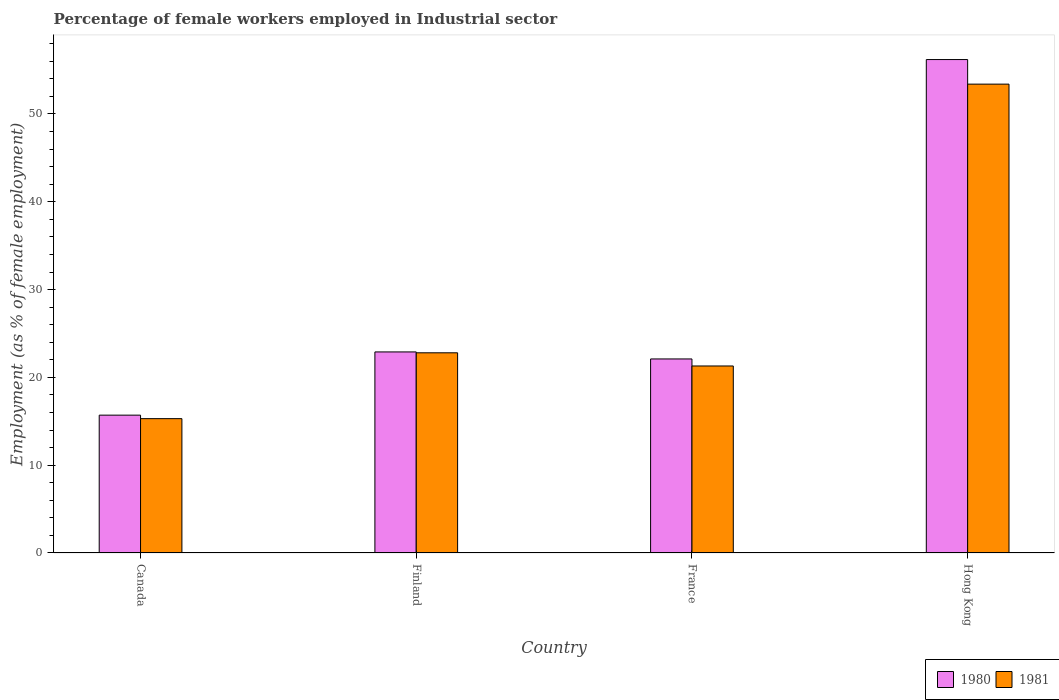How many bars are there on the 2nd tick from the left?
Ensure brevity in your answer.  2. How many bars are there on the 4th tick from the right?
Your answer should be compact. 2. What is the percentage of females employed in Industrial sector in 1980 in Canada?
Ensure brevity in your answer.  15.7. Across all countries, what is the maximum percentage of females employed in Industrial sector in 1981?
Ensure brevity in your answer.  53.4. Across all countries, what is the minimum percentage of females employed in Industrial sector in 1980?
Provide a succinct answer. 15.7. In which country was the percentage of females employed in Industrial sector in 1980 maximum?
Ensure brevity in your answer.  Hong Kong. What is the total percentage of females employed in Industrial sector in 1981 in the graph?
Give a very brief answer. 112.8. What is the difference between the percentage of females employed in Industrial sector in 1980 in Finland and that in France?
Offer a terse response. 0.8. What is the difference between the percentage of females employed in Industrial sector in 1980 in Finland and the percentage of females employed in Industrial sector in 1981 in Hong Kong?
Give a very brief answer. -30.5. What is the average percentage of females employed in Industrial sector in 1980 per country?
Your answer should be compact. 29.23. What is the difference between the percentage of females employed in Industrial sector of/in 1980 and percentage of females employed in Industrial sector of/in 1981 in Finland?
Your answer should be compact. 0.1. In how many countries, is the percentage of females employed in Industrial sector in 1980 greater than 40 %?
Your response must be concise. 1. What is the ratio of the percentage of females employed in Industrial sector in 1980 in Canada to that in France?
Your response must be concise. 0.71. Is the difference between the percentage of females employed in Industrial sector in 1980 in Finland and Hong Kong greater than the difference between the percentage of females employed in Industrial sector in 1981 in Finland and Hong Kong?
Provide a short and direct response. No. What is the difference between the highest and the second highest percentage of females employed in Industrial sector in 1980?
Offer a very short reply. 33.3. What is the difference between the highest and the lowest percentage of females employed in Industrial sector in 1980?
Your answer should be compact. 40.5. In how many countries, is the percentage of females employed in Industrial sector in 1980 greater than the average percentage of females employed in Industrial sector in 1980 taken over all countries?
Provide a short and direct response. 1. What does the 1st bar from the right in Finland represents?
Your response must be concise. 1981. Are all the bars in the graph horizontal?
Offer a very short reply. No. What is the difference between two consecutive major ticks on the Y-axis?
Give a very brief answer. 10. Where does the legend appear in the graph?
Your response must be concise. Bottom right. How many legend labels are there?
Provide a succinct answer. 2. How are the legend labels stacked?
Your answer should be compact. Horizontal. What is the title of the graph?
Offer a terse response. Percentage of female workers employed in Industrial sector. What is the label or title of the X-axis?
Give a very brief answer. Country. What is the label or title of the Y-axis?
Ensure brevity in your answer.  Employment (as % of female employment). What is the Employment (as % of female employment) of 1980 in Canada?
Your answer should be very brief. 15.7. What is the Employment (as % of female employment) of 1981 in Canada?
Make the answer very short. 15.3. What is the Employment (as % of female employment) of 1980 in Finland?
Offer a terse response. 22.9. What is the Employment (as % of female employment) in 1981 in Finland?
Provide a short and direct response. 22.8. What is the Employment (as % of female employment) in 1980 in France?
Provide a short and direct response. 22.1. What is the Employment (as % of female employment) of 1981 in France?
Give a very brief answer. 21.3. What is the Employment (as % of female employment) of 1980 in Hong Kong?
Provide a succinct answer. 56.2. What is the Employment (as % of female employment) in 1981 in Hong Kong?
Your answer should be very brief. 53.4. Across all countries, what is the maximum Employment (as % of female employment) in 1980?
Provide a short and direct response. 56.2. Across all countries, what is the maximum Employment (as % of female employment) in 1981?
Offer a terse response. 53.4. Across all countries, what is the minimum Employment (as % of female employment) in 1980?
Your answer should be compact. 15.7. Across all countries, what is the minimum Employment (as % of female employment) of 1981?
Provide a short and direct response. 15.3. What is the total Employment (as % of female employment) of 1980 in the graph?
Offer a very short reply. 116.9. What is the total Employment (as % of female employment) in 1981 in the graph?
Provide a short and direct response. 112.8. What is the difference between the Employment (as % of female employment) in 1980 in Canada and that in Finland?
Your response must be concise. -7.2. What is the difference between the Employment (as % of female employment) in 1980 in Canada and that in France?
Your response must be concise. -6.4. What is the difference between the Employment (as % of female employment) of 1980 in Canada and that in Hong Kong?
Give a very brief answer. -40.5. What is the difference between the Employment (as % of female employment) in 1981 in Canada and that in Hong Kong?
Your answer should be compact. -38.1. What is the difference between the Employment (as % of female employment) in 1980 in Finland and that in Hong Kong?
Your answer should be compact. -33.3. What is the difference between the Employment (as % of female employment) in 1981 in Finland and that in Hong Kong?
Make the answer very short. -30.6. What is the difference between the Employment (as % of female employment) in 1980 in France and that in Hong Kong?
Make the answer very short. -34.1. What is the difference between the Employment (as % of female employment) of 1981 in France and that in Hong Kong?
Your answer should be compact. -32.1. What is the difference between the Employment (as % of female employment) in 1980 in Canada and the Employment (as % of female employment) in 1981 in Finland?
Give a very brief answer. -7.1. What is the difference between the Employment (as % of female employment) of 1980 in Canada and the Employment (as % of female employment) of 1981 in Hong Kong?
Offer a very short reply. -37.7. What is the difference between the Employment (as % of female employment) of 1980 in Finland and the Employment (as % of female employment) of 1981 in France?
Your answer should be very brief. 1.6. What is the difference between the Employment (as % of female employment) in 1980 in Finland and the Employment (as % of female employment) in 1981 in Hong Kong?
Your response must be concise. -30.5. What is the difference between the Employment (as % of female employment) of 1980 in France and the Employment (as % of female employment) of 1981 in Hong Kong?
Offer a very short reply. -31.3. What is the average Employment (as % of female employment) in 1980 per country?
Ensure brevity in your answer.  29.23. What is the average Employment (as % of female employment) in 1981 per country?
Ensure brevity in your answer.  28.2. What is the difference between the Employment (as % of female employment) of 1980 and Employment (as % of female employment) of 1981 in Canada?
Provide a succinct answer. 0.4. What is the difference between the Employment (as % of female employment) of 1980 and Employment (as % of female employment) of 1981 in Hong Kong?
Your answer should be very brief. 2.8. What is the ratio of the Employment (as % of female employment) of 1980 in Canada to that in Finland?
Make the answer very short. 0.69. What is the ratio of the Employment (as % of female employment) in 1981 in Canada to that in Finland?
Offer a very short reply. 0.67. What is the ratio of the Employment (as % of female employment) in 1980 in Canada to that in France?
Make the answer very short. 0.71. What is the ratio of the Employment (as % of female employment) in 1981 in Canada to that in France?
Give a very brief answer. 0.72. What is the ratio of the Employment (as % of female employment) in 1980 in Canada to that in Hong Kong?
Your answer should be compact. 0.28. What is the ratio of the Employment (as % of female employment) in 1981 in Canada to that in Hong Kong?
Provide a short and direct response. 0.29. What is the ratio of the Employment (as % of female employment) in 1980 in Finland to that in France?
Keep it short and to the point. 1.04. What is the ratio of the Employment (as % of female employment) in 1981 in Finland to that in France?
Offer a terse response. 1.07. What is the ratio of the Employment (as % of female employment) in 1980 in Finland to that in Hong Kong?
Offer a terse response. 0.41. What is the ratio of the Employment (as % of female employment) in 1981 in Finland to that in Hong Kong?
Your answer should be very brief. 0.43. What is the ratio of the Employment (as % of female employment) in 1980 in France to that in Hong Kong?
Give a very brief answer. 0.39. What is the ratio of the Employment (as % of female employment) of 1981 in France to that in Hong Kong?
Give a very brief answer. 0.4. What is the difference between the highest and the second highest Employment (as % of female employment) in 1980?
Offer a very short reply. 33.3. What is the difference between the highest and the second highest Employment (as % of female employment) in 1981?
Ensure brevity in your answer.  30.6. What is the difference between the highest and the lowest Employment (as % of female employment) of 1980?
Make the answer very short. 40.5. What is the difference between the highest and the lowest Employment (as % of female employment) in 1981?
Keep it short and to the point. 38.1. 